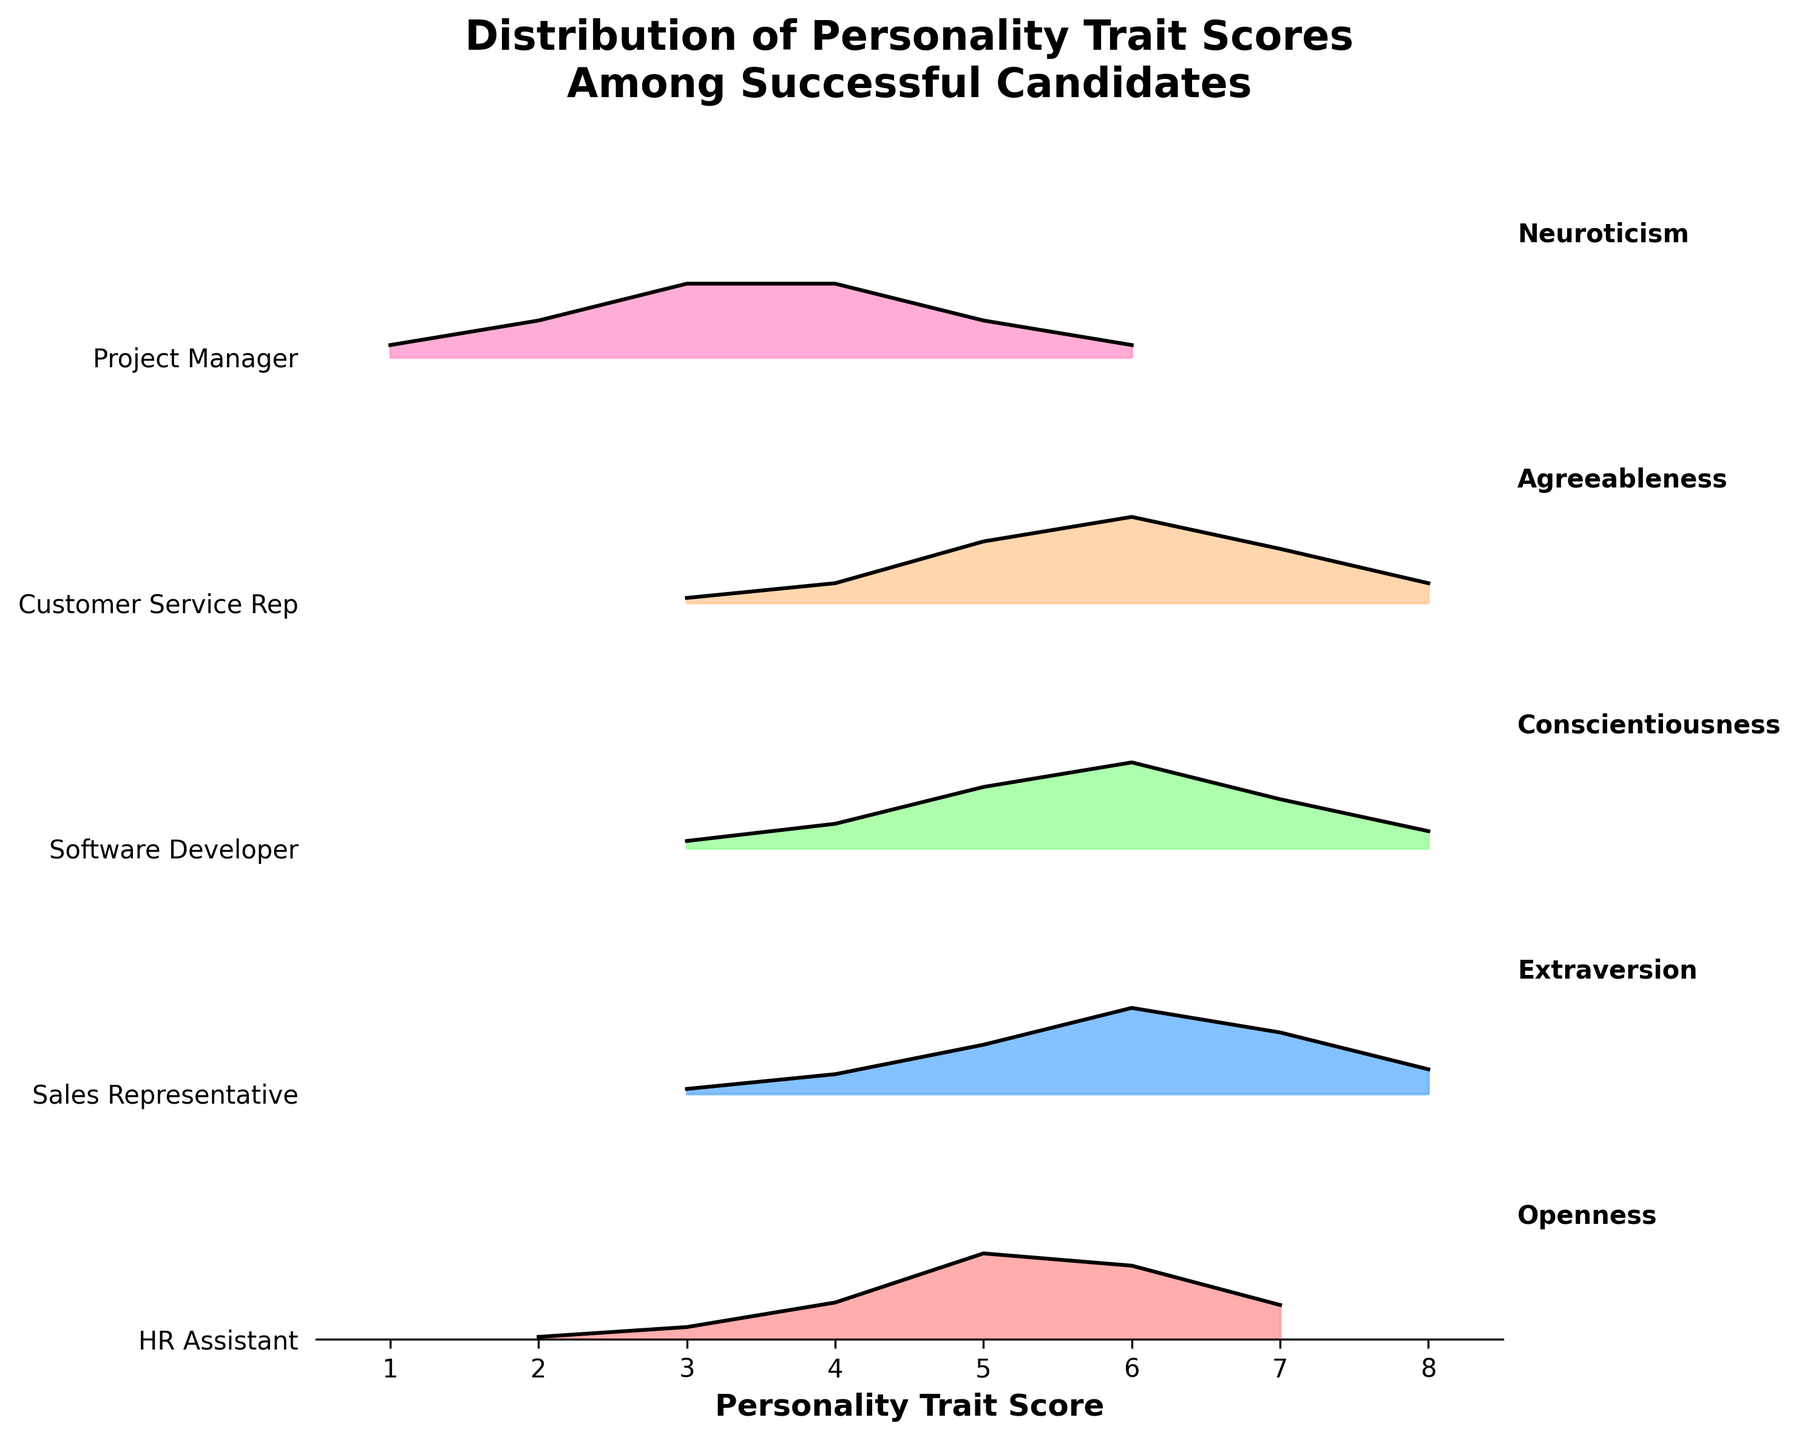How many different job roles are displayed in the figure? The y-axis displays labels for each job role. Counting these labels shows how many different job roles are included.
Answer: 5 What is the title of the plot? The title is usually displayed at the top of the plot, indicating the main subject.
Answer: Distribution of Personality Trait Scores Among Successful Candidates For the HR Assistant role, what score range has the highest density for Openness? Look at the HR Assistant layer on the plot and find the highest peak in the Openness distribution, which is where the density is greatest.
Answer: 4-6 Which job role has the lowest density at the highest personality trait score? Look at the rightmost part of the plot and observe each job role's density value at the highest trait score.
Answer: Sales Representative Compare the score ranges where the peak densities occur for the Customer Service Rep and Project Manager. Which one has a broader range for its peak density? Look at the peaks for both roles and note the range of scores around the peak density values for each.
Answer: Customer Service Rep What color is used to represent the Software Developer role? Identify the color used to fill the area under the curve for the Software Developer's personality trait distribution.
Answer: Light Green (hex: #99FF99) At which score does the Project Manager's Neuroticism begin to decline in density? Find the point in the Project Manager plot where the density starts to decrease from its peak.
Answer: 3 Which personality trait score does the Sales Representative most frequently achieve? Determine the highest density value for the Sales Representative and note the corresponding score.
Answer: 6 Is there any job role where the trait distribution appears symmetrical, and if so, which one? Look at the shape of each trait distribution and find if any of them appear symmetrical.
Answer: Project Manager Between the Software Developer and the Customer Service Rep, which role shows a higher peak density for its respective personality trait? Compare the highest density points in the distributions for both roles.
Answer: Customer Service Rep 